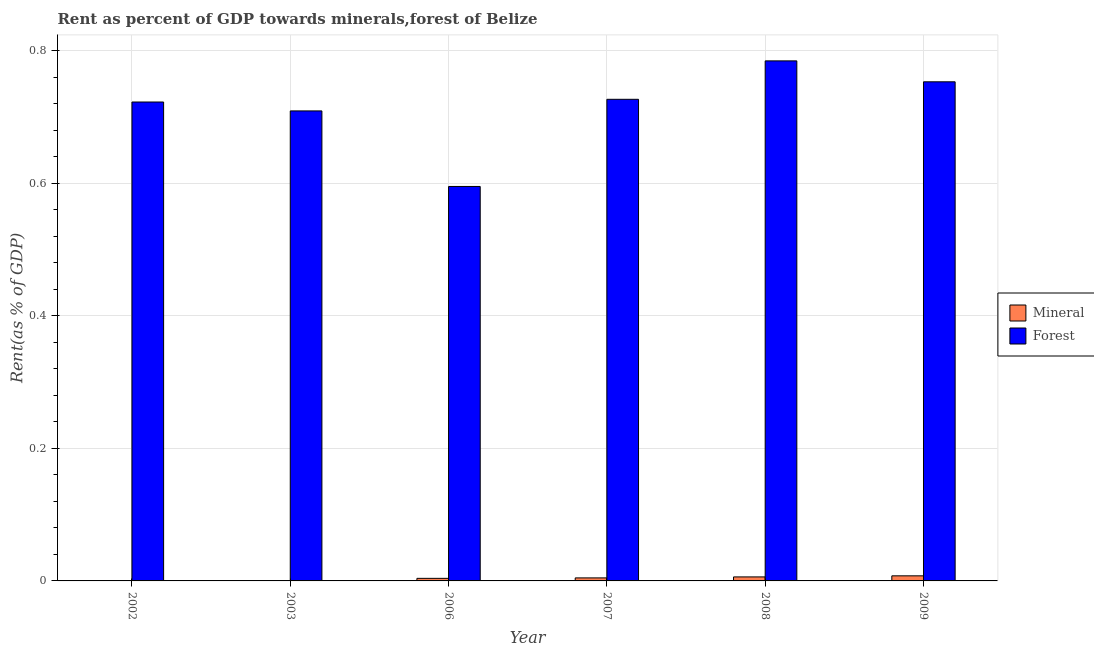How many different coloured bars are there?
Provide a succinct answer. 2. Are the number of bars per tick equal to the number of legend labels?
Keep it short and to the point. Yes. Are the number of bars on each tick of the X-axis equal?
Make the answer very short. Yes. What is the label of the 1st group of bars from the left?
Ensure brevity in your answer.  2002. What is the forest rent in 2008?
Your response must be concise. 0.78. Across all years, what is the maximum forest rent?
Your answer should be compact. 0.78. Across all years, what is the minimum mineral rent?
Provide a short and direct response. 0. In which year was the forest rent maximum?
Offer a terse response. 2008. What is the total mineral rent in the graph?
Your response must be concise. 0.02. What is the difference between the forest rent in 2008 and that in 2009?
Offer a terse response. 0.03. What is the difference between the forest rent in 2006 and the mineral rent in 2007?
Ensure brevity in your answer.  -0.13. What is the average forest rent per year?
Make the answer very short. 0.71. In the year 2007, what is the difference between the mineral rent and forest rent?
Provide a succinct answer. 0. In how many years, is the forest rent greater than 0.52 %?
Make the answer very short. 6. What is the ratio of the mineral rent in 2002 to that in 2009?
Offer a terse response. 0.02. Is the difference between the mineral rent in 2003 and 2006 greater than the difference between the forest rent in 2003 and 2006?
Provide a succinct answer. No. What is the difference between the highest and the second highest forest rent?
Make the answer very short. 0.03. What is the difference between the highest and the lowest forest rent?
Ensure brevity in your answer.  0.19. In how many years, is the forest rent greater than the average forest rent taken over all years?
Your answer should be compact. 4. Is the sum of the forest rent in 2002 and 2008 greater than the maximum mineral rent across all years?
Keep it short and to the point. Yes. What does the 2nd bar from the left in 2009 represents?
Offer a very short reply. Forest. What does the 1st bar from the right in 2008 represents?
Your answer should be very brief. Forest. Are all the bars in the graph horizontal?
Your response must be concise. No. How many years are there in the graph?
Ensure brevity in your answer.  6. How many legend labels are there?
Keep it short and to the point. 2. What is the title of the graph?
Offer a very short reply. Rent as percent of GDP towards minerals,forest of Belize. Does "Tetanus" appear as one of the legend labels in the graph?
Provide a short and direct response. No. What is the label or title of the X-axis?
Your answer should be compact. Year. What is the label or title of the Y-axis?
Your answer should be compact. Rent(as % of GDP). What is the Rent(as % of GDP) of Mineral in 2002?
Give a very brief answer. 0. What is the Rent(as % of GDP) in Forest in 2002?
Your answer should be very brief. 0.72. What is the Rent(as % of GDP) of Mineral in 2003?
Keep it short and to the point. 0. What is the Rent(as % of GDP) in Forest in 2003?
Offer a very short reply. 0.71. What is the Rent(as % of GDP) of Mineral in 2006?
Ensure brevity in your answer.  0. What is the Rent(as % of GDP) of Forest in 2006?
Provide a short and direct response. 0.59. What is the Rent(as % of GDP) of Mineral in 2007?
Offer a very short reply. 0. What is the Rent(as % of GDP) of Forest in 2007?
Ensure brevity in your answer.  0.73. What is the Rent(as % of GDP) of Mineral in 2008?
Offer a terse response. 0.01. What is the Rent(as % of GDP) of Forest in 2008?
Your answer should be very brief. 0.78. What is the Rent(as % of GDP) in Mineral in 2009?
Provide a short and direct response. 0.01. What is the Rent(as % of GDP) in Forest in 2009?
Your answer should be very brief. 0.75. Across all years, what is the maximum Rent(as % of GDP) in Mineral?
Ensure brevity in your answer.  0.01. Across all years, what is the maximum Rent(as % of GDP) in Forest?
Provide a succinct answer. 0.78. Across all years, what is the minimum Rent(as % of GDP) of Mineral?
Ensure brevity in your answer.  0. Across all years, what is the minimum Rent(as % of GDP) in Forest?
Provide a succinct answer. 0.59. What is the total Rent(as % of GDP) in Mineral in the graph?
Offer a very short reply. 0.02. What is the total Rent(as % of GDP) of Forest in the graph?
Offer a terse response. 4.29. What is the difference between the Rent(as % of GDP) in Mineral in 2002 and that in 2003?
Your answer should be very brief. -0. What is the difference between the Rent(as % of GDP) of Forest in 2002 and that in 2003?
Provide a short and direct response. 0.01. What is the difference between the Rent(as % of GDP) of Mineral in 2002 and that in 2006?
Your answer should be compact. -0. What is the difference between the Rent(as % of GDP) in Forest in 2002 and that in 2006?
Give a very brief answer. 0.13. What is the difference between the Rent(as % of GDP) in Mineral in 2002 and that in 2007?
Your response must be concise. -0. What is the difference between the Rent(as % of GDP) of Forest in 2002 and that in 2007?
Give a very brief answer. -0. What is the difference between the Rent(as % of GDP) in Mineral in 2002 and that in 2008?
Keep it short and to the point. -0.01. What is the difference between the Rent(as % of GDP) in Forest in 2002 and that in 2008?
Ensure brevity in your answer.  -0.06. What is the difference between the Rent(as % of GDP) of Mineral in 2002 and that in 2009?
Provide a short and direct response. -0.01. What is the difference between the Rent(as % of GDP) in Forest in 2002 and that in 2009?
Your answer should be very brief. -0.03. What is the difference between the Rent(as % of GDP) of Mineral in 2003 and that in 2006?
Offer a very short reply. -0. What is the difference between the Rent(as % of GDP) in Forest in 2003 and that in 2006?
Provide a short and direct response. 0.11. What is the difference between the Rent(as % of GDP) in Mineral in 2003 and that in 2007?
Your answer should be very brief. -0. What is the difference between the Rent(as % of GDP) in Forest in 2003 and that in 2007?
Your answer should be very brief. -0.02. What is the difference between the Rent(as % of GDP) in Mineral in 2003 and that in 2008?
Offer a very short reply. -0.01. What is the difference between the Rent(as % of GDP) of Forest in 2003 and that in 2008?
Keep it short and to the point. -0.08. What is the difference between the Rent(as % of GDP) in Mineral in 2003 and that in 2009?
Keep it short and to the point. -0.01. What is the difference between the Rent(as % of GDP) of Forest in 2003 and that in 2009?
Provide a succinct answer. -0.04. What is the difference between the Rent(as % of GDP) of Mineral in 2006 and that in 2007?
Give a very brief answer. -0. What is the difference between the Rent(as % of GDP) of Forest in 2006 and that in 2007?
Your answer should be compact. -0.13. What is the difference between the Rent(as % of GDP) of Mineral in 2006 and that in 2008?
Your response must be concise. -0. What is the difference between the Rent(as % of GDP) in Forest in 2006 and that in 2008?
Keep it short and to the point. -0.19. What is the difference between the Rent(as % of GDP) in Mineral in 2006 and that in 2009?
Make the answer very short. -0. What is the difference between the Rent(as % of GDP) in Forest in 2006 and that in 2009?
Keep it short and to the point. -0.16. What is the difference between the Rent(as % of GDP) of Mineral in 2007 and that in 2008?
Offer a terse response. -0. What is the difference between the Rent(as % of GDP) of Forest in 2007 and that in 2008?
Ensure brevity in your answer.  -0.06. What is the difference between the Rent(as % of GDP) of Mineral in 2007 and that in 2009?
Your answer should be very brief. -0. What is the difference between the Rent(as % of GDP) of Forest in 2007 and that in 2009?
Provide a short and direct response. -0.03. What is the difference between the Rent(as % of GDP) of Mineral in 2008 and that in 2009?
Offer a very short reply. -0. What is the difference between the Rent(as % of GDP) in Forest in 2008 and that in 2009?
Offer a very short reply. 0.03. What is the difference between the Rent(as % of GDP) of Mineral in 2002 and the Rent(as % of GDP) of Forest in 2003?
Your answer should be compact. -0.71. What is the difference between the Rent(as % of GDP) of Mineral in 2002 and the Rent(as % of GDP) of Forest in 2006?
Ensure brevity in your answer.  -0.59. What is the difference between the Rent(as % of GDP) in Mineral in 2002 and the Rent(as % of GDP) in Forest in 2007?
Your response must be concise. -0.73. What is the difference between the Rent(as % of GDP) of Mineral in 2002 and the Rent(as % of GDP) of Forest in 2008?
Ensure brevity in your answer.  -0.78. What is the difference between the Rent(as % of GDP) of Mineral in 2002 and the Rent(as % of GDP) of Forest in 2009?
Offer a very short reply. -0.75. What is the difference between the Rent(as % of GDP) of Mineral in 2003 and the Rent(as % of GDP) of Forest in 2006?
Your answer should be compact. -0.59. What is the difference between the Rent(as % of GDP) in Mineral in 2003 and the Rent(as % of GDP) in Forest in 2007?
Provide a short and direct response. -0.73. What is the difference between the Rent(as % of GDP) of Mineral in 2003 and the Rent(as % of GDP) of Forest in 2008?
Your answer should be compact. -0.78. What is the difference between the Rent(as % of GDP) in Mineral in 2003 and the Rent(as % of GDP) in Forest in 2009?
Your response must be concise. -0.75. What is the difference between the Rent(as % of GDP) of Mineral in 2006 and the Rent(as % of GDP) of Forest in 2007?
Provide a succinct answer. -0.72. What is the difference between the Rent(as % of GDP) of Mineral in 2006 and the Rent(as % of GDP) of Forest in 2008?
Make the answer very short. -0.78. What is the difference between the Rent(as % of GDP) of Mineral in 2006 and the Rent(as % of GDP) of Forest in 2009?
Your answer should be compact. -0.75. What is the difference between the Rent(as % of GDP) of Mineral in 2007 and the Rent(as % of GDP) of Forest in 2008?
Make the answer very short. -0.78. What is the difference between the Rent(as % of GDP) in Mineral in 2007 and the Rent(as % of GDP) in Forest in 2009?
Keep it short and to the point. -0.75. What is the difference between the Rent(as % of GDP) of Mineral in 2008 and the Rent(as % of GDP) of Forest in 2009?
Your answer should be very brief. -0.75. What is the average Rent(as % of GDP) in Mineral per year?
Your answer should be very brief. 0. What is the average Rent(as % of GDP) of Forest per year?
Your answer should be compact. 0.71. In the year 2002, what is the difference between the Rent(as % of GDP) of Mineral and Rent(as % of GDP) of Forest?
Ensure brevity in your answer.  -0.72. In the year 2003, what is the difference between the Rent(as % of GDP) in Mineral and Rent(as % of GDP) in Forest?
Offer a very short reply. -0.71. In the year 2006, what is the difference between the Rent(as % of GDP) of Mineral and Rent(as % of GDP) of Forest?
Your answer should be compact. -0.59. In the year 2007, what is the difference between the Rent(as % of GDP) of Mineral and Rent(as % of GDP) of Forest?
Offer a very short reply. -0.72. In the year 2008, what is the difference between the Rent(as % of GDP) of Mineral and Rent(as % of GDP) of Forest?
Provide a short and direct response. -0.78. In the year 2009, what is the difference between the Rent(as % of GDP) in Mineral and Rent(as % of GDP) in Forest?
Your answer should be compact. -0.75. What is the ratio of the Rent(as % of GDP) of Mineral in 2002 to that in 2003?
Offer a terse response. 0.58. What is the ratio of the Rent(as % of GDP) of Forest in 2002 to that in 2003?
Give a very brief answer. 1.02. What is the ratio of the Rent(as % of GDP) of Mineral in 2002 to that in 2006?
Give a very brief answer. 0.04. What is the ratio of the Rent(as % of GDP) of Forest in 2002 to that in 2006?
Offer a very short reply. 1.21. What is the ratio of the Rent(as % of GDP) of Mineral in 2002 to that in 2007?
Your response must be concise. 0.04. What is the ratio of the Rent(as % of GDP) of Forest in 2002 to that in 2007?
Your answer should be very brief. 0.99. What is the ratio of the Rent(as % of GDP) of Mineral in 2002 to that in 2008?
Make the answer very short. 0.03. What is the ratio of the Rent(as % of GDP) in Forest in 2002 to that in 2008?
Keep it short and to the point. 0.92. What is the ratio of the Rent(as % of GDP) in Mineral in 2002 to that in 2009?
Make the answer very short. 0.02. What is the ratio of the Rent(as % of GDP) in Forest in 2002 to that in 2009?
Your response must be concise. 0.96. What is the ratio of the Rent(as % of GDP) of Mineral in 2003 to that in 2006?
Provide a short and direct response. 0.07. What is the ratio of the Rent(as % of GDP) in Forest in 2003 to that in 2006?
Offer a very short reply. 1.19. What is the ratio of the Rent(as % of GDP) in Mineral in 2003 to that in 2007?
Your answer should be compact. 0.06. What is the ratio of the Rent(as % of GDP) of Forest in 2003 to that in 2007?
Give a very brief answer. 0.98. What is the ratio of the Rent(as % of GDP) in Mineral in 2003 to that in 2008?
Give a very brief answer. 0.05. What is the ratio of the Rent(as % of GDP) in Forest in 2003 to that in 2008?
Your answer should be compact. 0.9. What is the ratio of the Rent(as % of GDP) in Mineral in 2003 to that in 2009?
Provide a succinct answer. 0.04. What is the ratio of the Rent(as % of GDP) of Forest in 2003 to that in 2009?
Your answer should be very brief. 0.94. What is the ratio of the Rent(as % of GDP) in Mineral in 2006 to that in 2007?
Offer a very short reply. 0.85. What is the ratio of the Rent(as % of GDP) in Forest in 2006 to that in 2007?
Ensure brevity in your answer.  0.82. What is the ratio of the Rent(as % of GDP) of Mineral in 2006 to that in 2008?
Provide a succinct answer. 0.64. What is the ratio of the Rent(as % of GDP) in Forest in 2006 to that in 2008?
Your response must be concise. 0.76. What is the ratio of the Rent(as % of GDP) of Mineral in 2006 to that in 2009?
Make the answer very short. 0.5. What is the ratio of the Rent(as % of GDP) in Forest in 2006 to that in 2009?
Offer a very short reply. 0.79. What is the ratio of the Rent(as % of GDP) of Mineral in 2007 to that in 2008?
Keep it short and to the point. 0.75. What is the ratio of the Rent(as % of GDP) of Forest in 2007 to that in 2008?
Offer a terse response. 0.93. What is the ratio of the Rent(as % of GDP) in Mineral in 2007 to that in 2009?
Offer a very short reply. 0.59. What is the ratio of the Rent(as % of GDP) in Mineral in 2008 to that in 2009?
Your answer should be very brief. 0.79. What is the ratio of the Rent(as % of GDP) of Forest in 2008 to that in 2009?
Provide a succinct answer. 1.04. What is the difference between the highest and the second highest Rent(as % of GDP) of Mineral?
Ensure brevity in your answer.  0. What is the difference between the highest and the second highest Rent(as % of GDP) of Forest?
Make the answer very short. 0.03. What is the difference between the highest and the lowest Rent(as % of GDP) of Mineral?
Provide a short and direct response. 0.01. What is the difference between the highest and the lowest Rent(as % of GDP) in Forest?
Give a very brief answer. 0.19. 